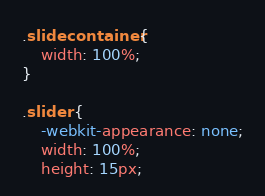<code> <loc_0><loc_0><loc_500><loc_500><_CSS_>.slidecontainer {
    width: 100%;
}

.slider {
    -webkit-appearance: none;
    width: 100%;
    height: 15px;</code> 